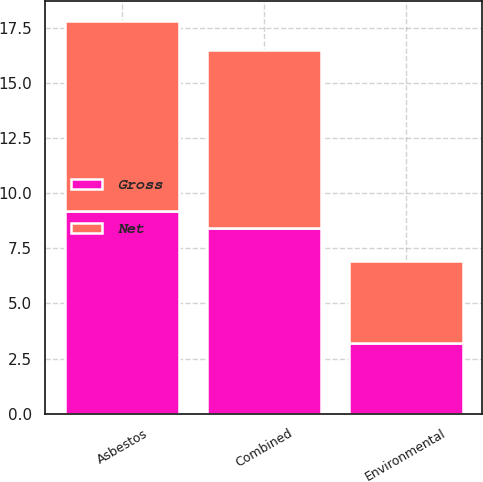Convert chart to OTSL. <chart><loc_0><loc_0><loc_500><loc_500><stacked_bar_chart><ecel><fcel>Asbestos<fcel>Environmental<fcel>Combined<nl><fcel>Net<fcel>8.6<fcel>3.7<fcel>8.1<nl><fcel>Gross<fcel>9.2<fcel>3.2<fcel>8.4<nl></chart> 